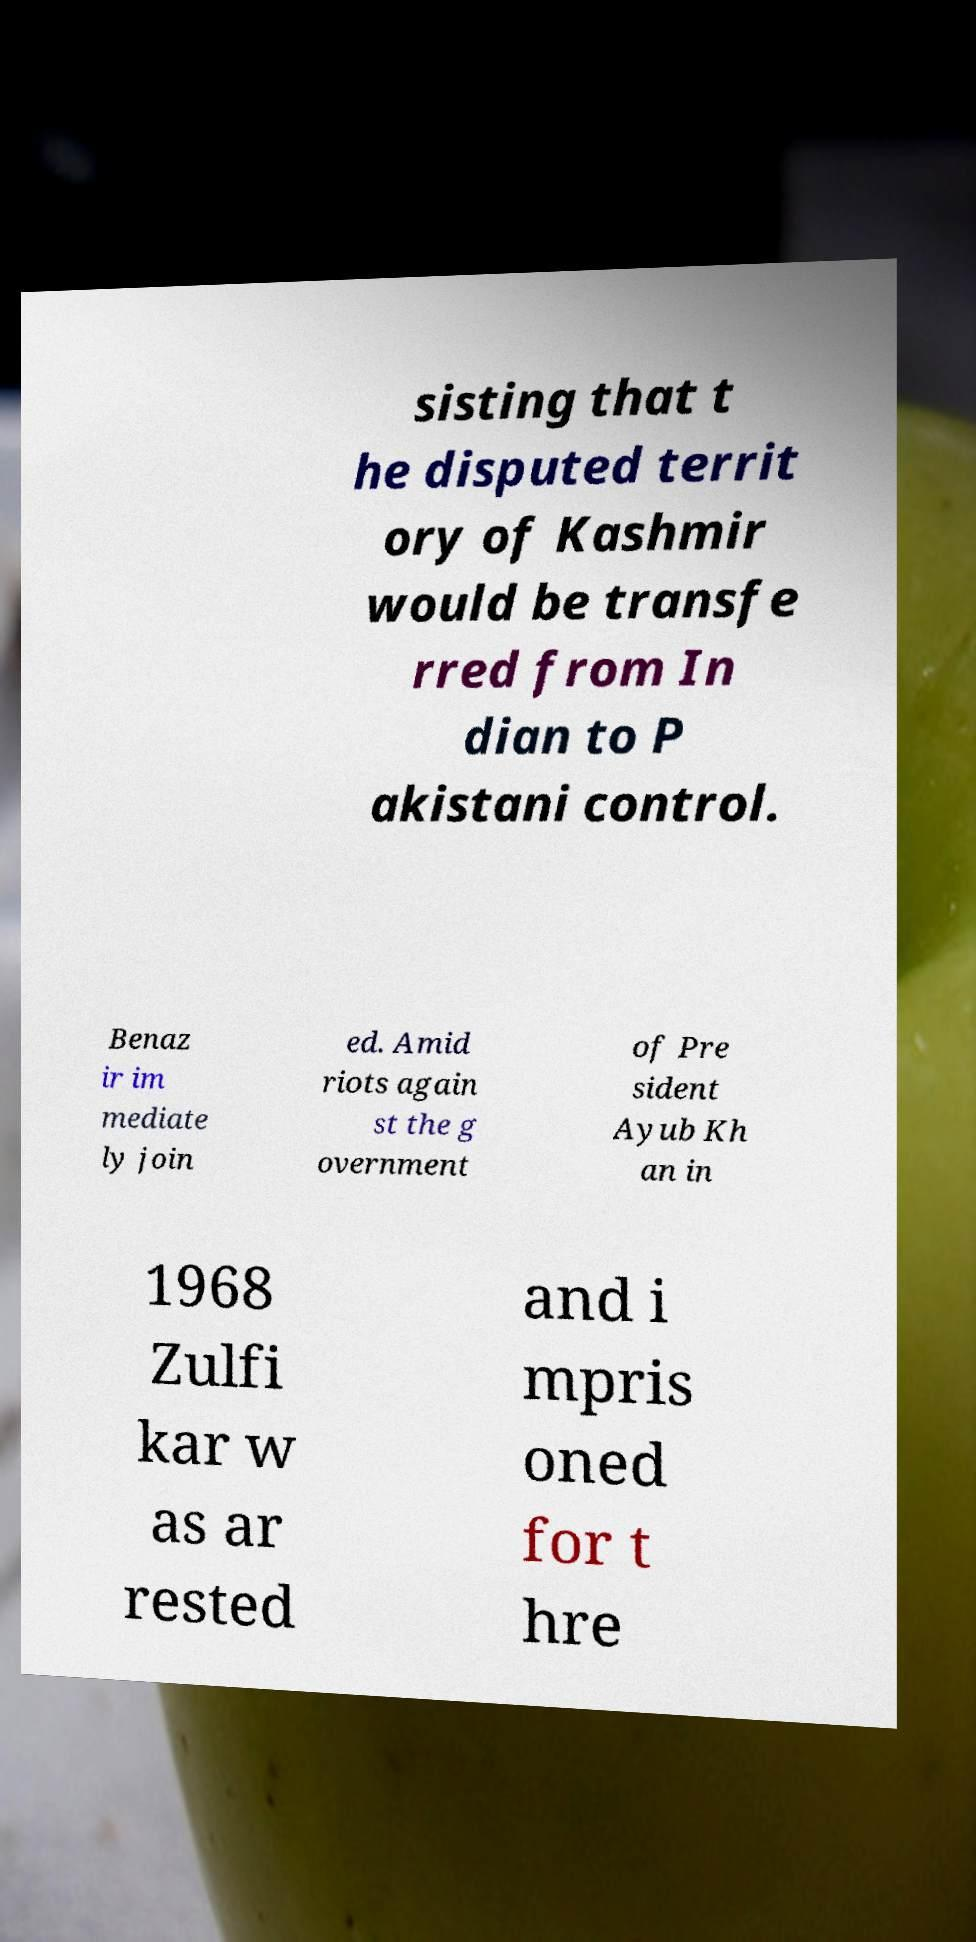Please read and relay the text visible in this image. What does it say? sisting that t he disputed territ ory of Kashmir would be transfe rred from In dian to P akistani control. Benaz ir im mediate ly join ed. Amid riots again st the g overnment of Pre sident Ayub Kh an in 1968 Zulfi kar w as ar rested and i mpris oned for t hre 